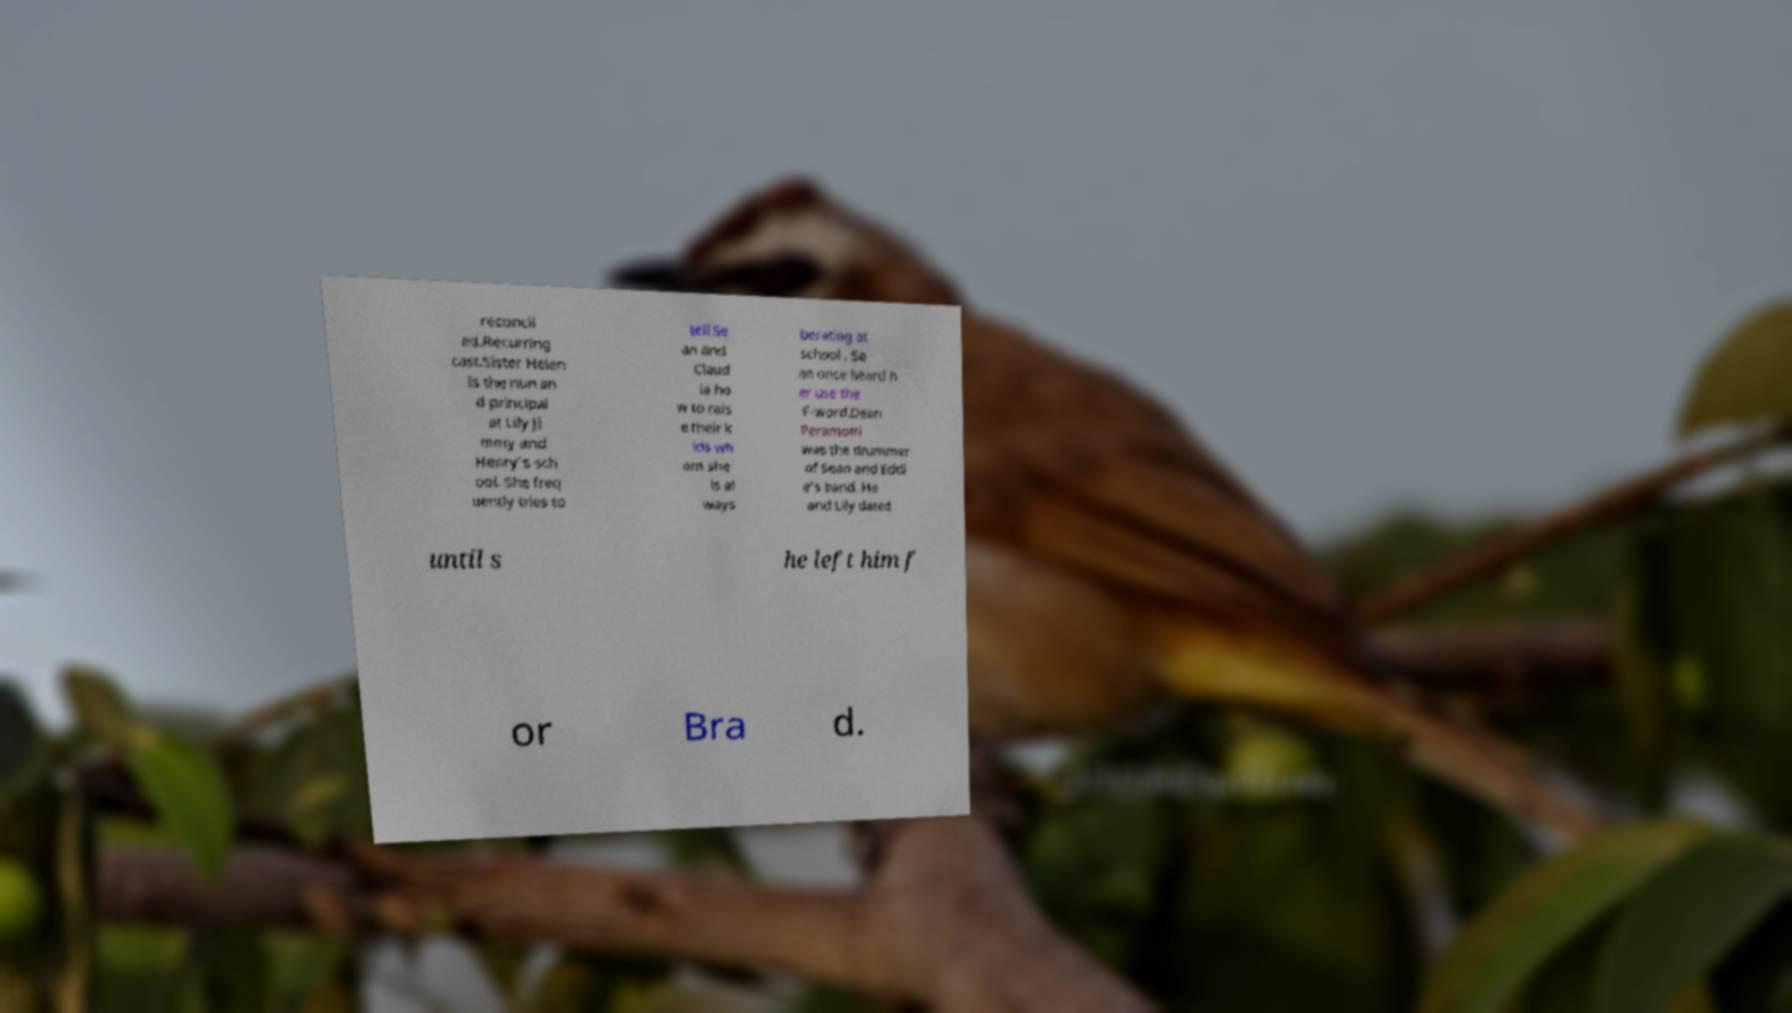Can you accurately transcribe the text from the provided image for me? reconcil ed.Recurring cast.Sister Helen is the nun an d principal at Lily Ji mmy and Henry's sch ool. She freq uently tries to tell Se an and Claud ia ho w to rais e their k ids wh om she is al ways berating at school . Se an once heard h er use the F-word.Dean Peramotti was the drummer of Sean and Eddi e's band. He and Lily dated until s he left him f or Bra d. 